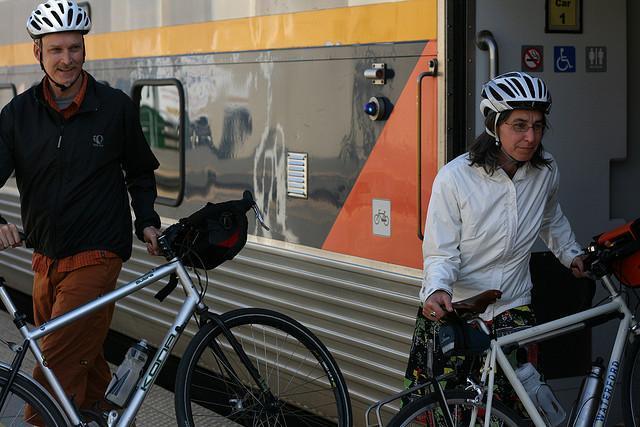How many bikes are in the photo?
Give a very brief answer. 2. How many bicycles are there?
Give a very brief answer. 2. How many people are there?
Give a very brief answer. 2. How many buses are double-decker buses?
Give a very brief answer. 0. 